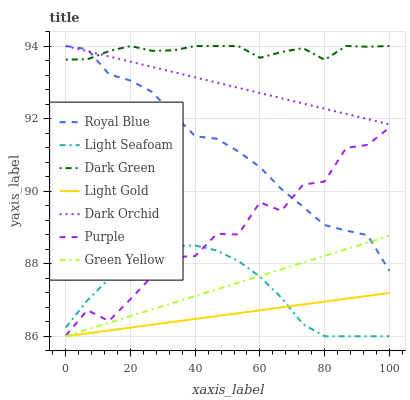Does Light Gold have the minimum area under the curve?
Answer yes or no. Yes. Does Dark Green have the maximum area under the curve?
Answer yes or no. Yes. Does Purple have the minimum area under the curve?
Answer yes or no. No. Does Purple have the maximum area under the curve?
Answer yes or no. No. Is Green Yellow the smoothest?
Answer yes or no. Yes. Is Purple the roughest?
Answer yes or no. Yes. Is Dark Orchid the smoothest?
Answer yes or no. No. Is Dark Orchid the roughest?
Answer yes or no. No. Does Green Yellow have the lowest value?
Answer yes or no. Yes. Does Purple have the lowest value?
Answer yes or no. No. Does Dark Green have the highest value?
Answer yes or no. Yes. Does Purple have the highest value?
Answer yes or no. No. Is Light Gold less than Purple?
Answer yes or no. Yes. Is Dark Green greater than Purple?
Answer yes or no. Yes. Does Light Seafoam intersect Green Yellow?
Answer yes or no. Yes. Is Light Seafoam less than Green Yellow?
Answer yes or no. No. Is Light Seafoam greater than Green Yellow?
Answer yes or no. No. Does Light Gold intersect Purple?
Answer yes or no. No. 